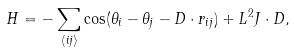<formula> <loc_0><loc_0><loc_500><loc_500>H = - \sum _ { \langle i j \rangle } \cos ( \theta _ { i } - \theta _ { j } - D \cdot r _ { i j } ) + L ^ { 2 } J \cdot D ,</formula> 